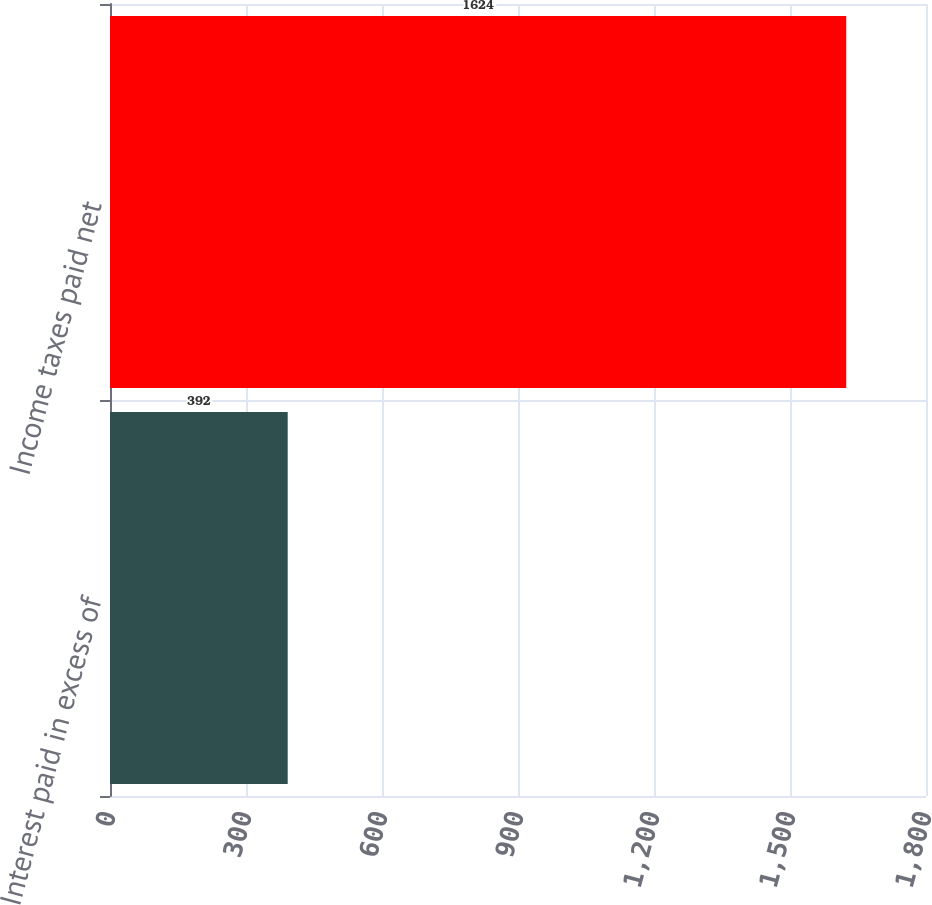<chart> <loc_0><loc_0><loc_500><loc_500><bar_chart><fcel>Interest paid in excess of<fcel>Income taxes paid net<nl><fcel>392<fcel>1624<nl></chart> 